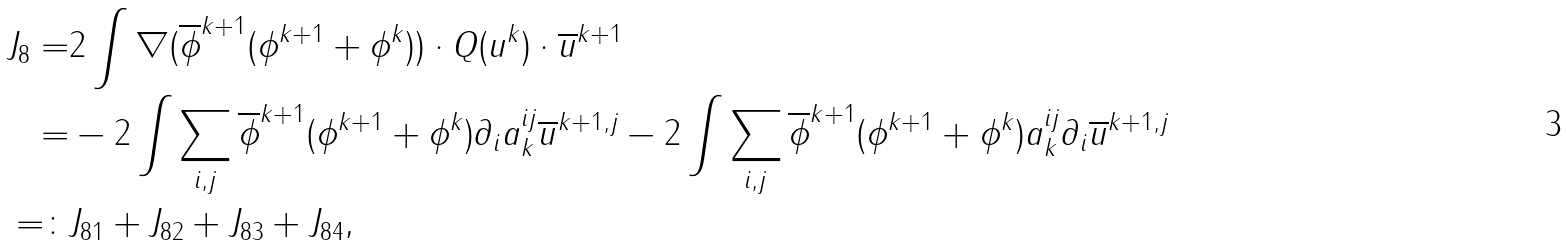Convert formula to latex. <formula><loc_0><loc_0><loc_500><loc_500>J _ { 8 } = & 2 \int \nabla ( \overline { \phi } ^ { k + 1 } ( \phi ^ { k + 1 } + \phi ^ { k } ) ) \cdot Q ( u ^ { k } ) \cdot \overline { u } ^ { k + 1 } \\ = & - 2 \int \sum _ { i , j } \overline { \phi } ^ { k + 1 } ( \phi ^ { k + 1 } + \phi ^ { k } ) \partial _ { i } a ^ { i j } _ { k } \overline { u } ^ { k + 1 , j } - 2 \int \sum _ { i , j } \overline { \phi } ^ { k + 1 } ( \phi ^ { k + 1 } + \phi ^ { k } ) a ^ { i j } _ { k } \partial _ { i } \overline { u } ^ { k + 1 , j } \\ = \colon & J _ { 8 1 } + J _ { 8 2 } + J _ { 8 3 } + J _ { 8 4 } ,</formula> 